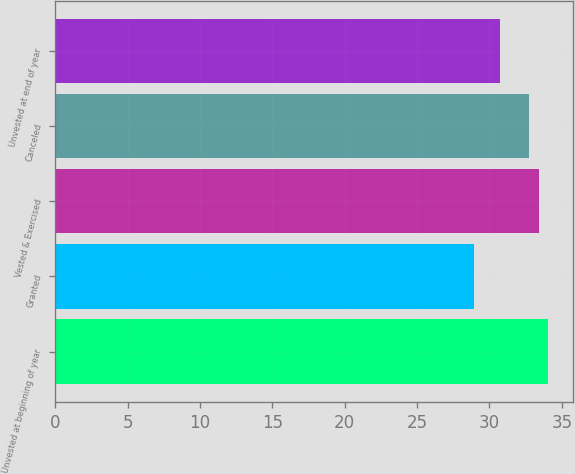Convert chart. <chart><loc_0><loc_0><loc_500><loc_500><bar_chart><fcel>Unvested at beginning of year<fcel>Granted<fcel>Vested & Exercised<fcel>Canceled<fcel>Unvested at end of year<nl><fcel>34.04<fcel>28.9<fcel>33.4<fcel>32.7<fcel>30.76<nl></chart> 